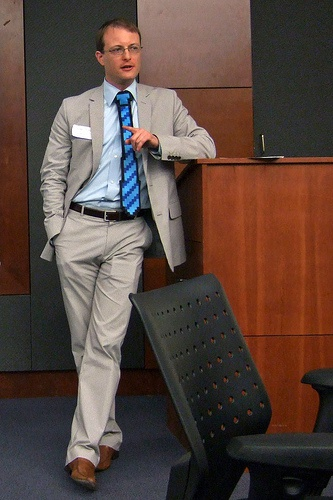Describe the objects in this image and their specific colors. I can see people in gray, darkgray, and black tones, chair in gray and black tones, and tie in gray, lightblue, blue, black, and navy tones in this image. 